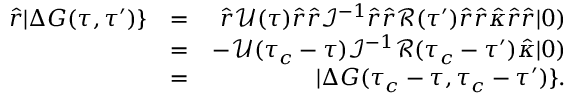Convert formula to latex. <formula><loc_0><loc_0><loc_500><loc_500>\begin{array} { r l r } { \hat { r } | \Delta G ( \tau , \tau ^ { \prime } ) \} } & { = } & { \hat { r } \mathcal { U } ( \tau ) \hat { r } \hat { r } \mathcal { I } ^ { - 1 } \hat { r } \hat { r } \mathcal { R } ( \tau ^ { \prime } ) \hat { r } \hat { r } \hat { \kappa } \hat { r } \hat { r } | 0 ) } \\ & { = } & { - \mathcal { U } ( \tau _ { c } - \tau ) \mathcal { I } ^ { - 1 } \mathcal { R } ( \tau _ { c } - \tau ^ { \prime } ) \hat { \kappa } | 0 ) } \\ & { = } & { | \Delta G ( \tau _ { c } - \tau , \tau _ { c } - \tau ^ { \prime } ) \} . } \end{array}</formula> 